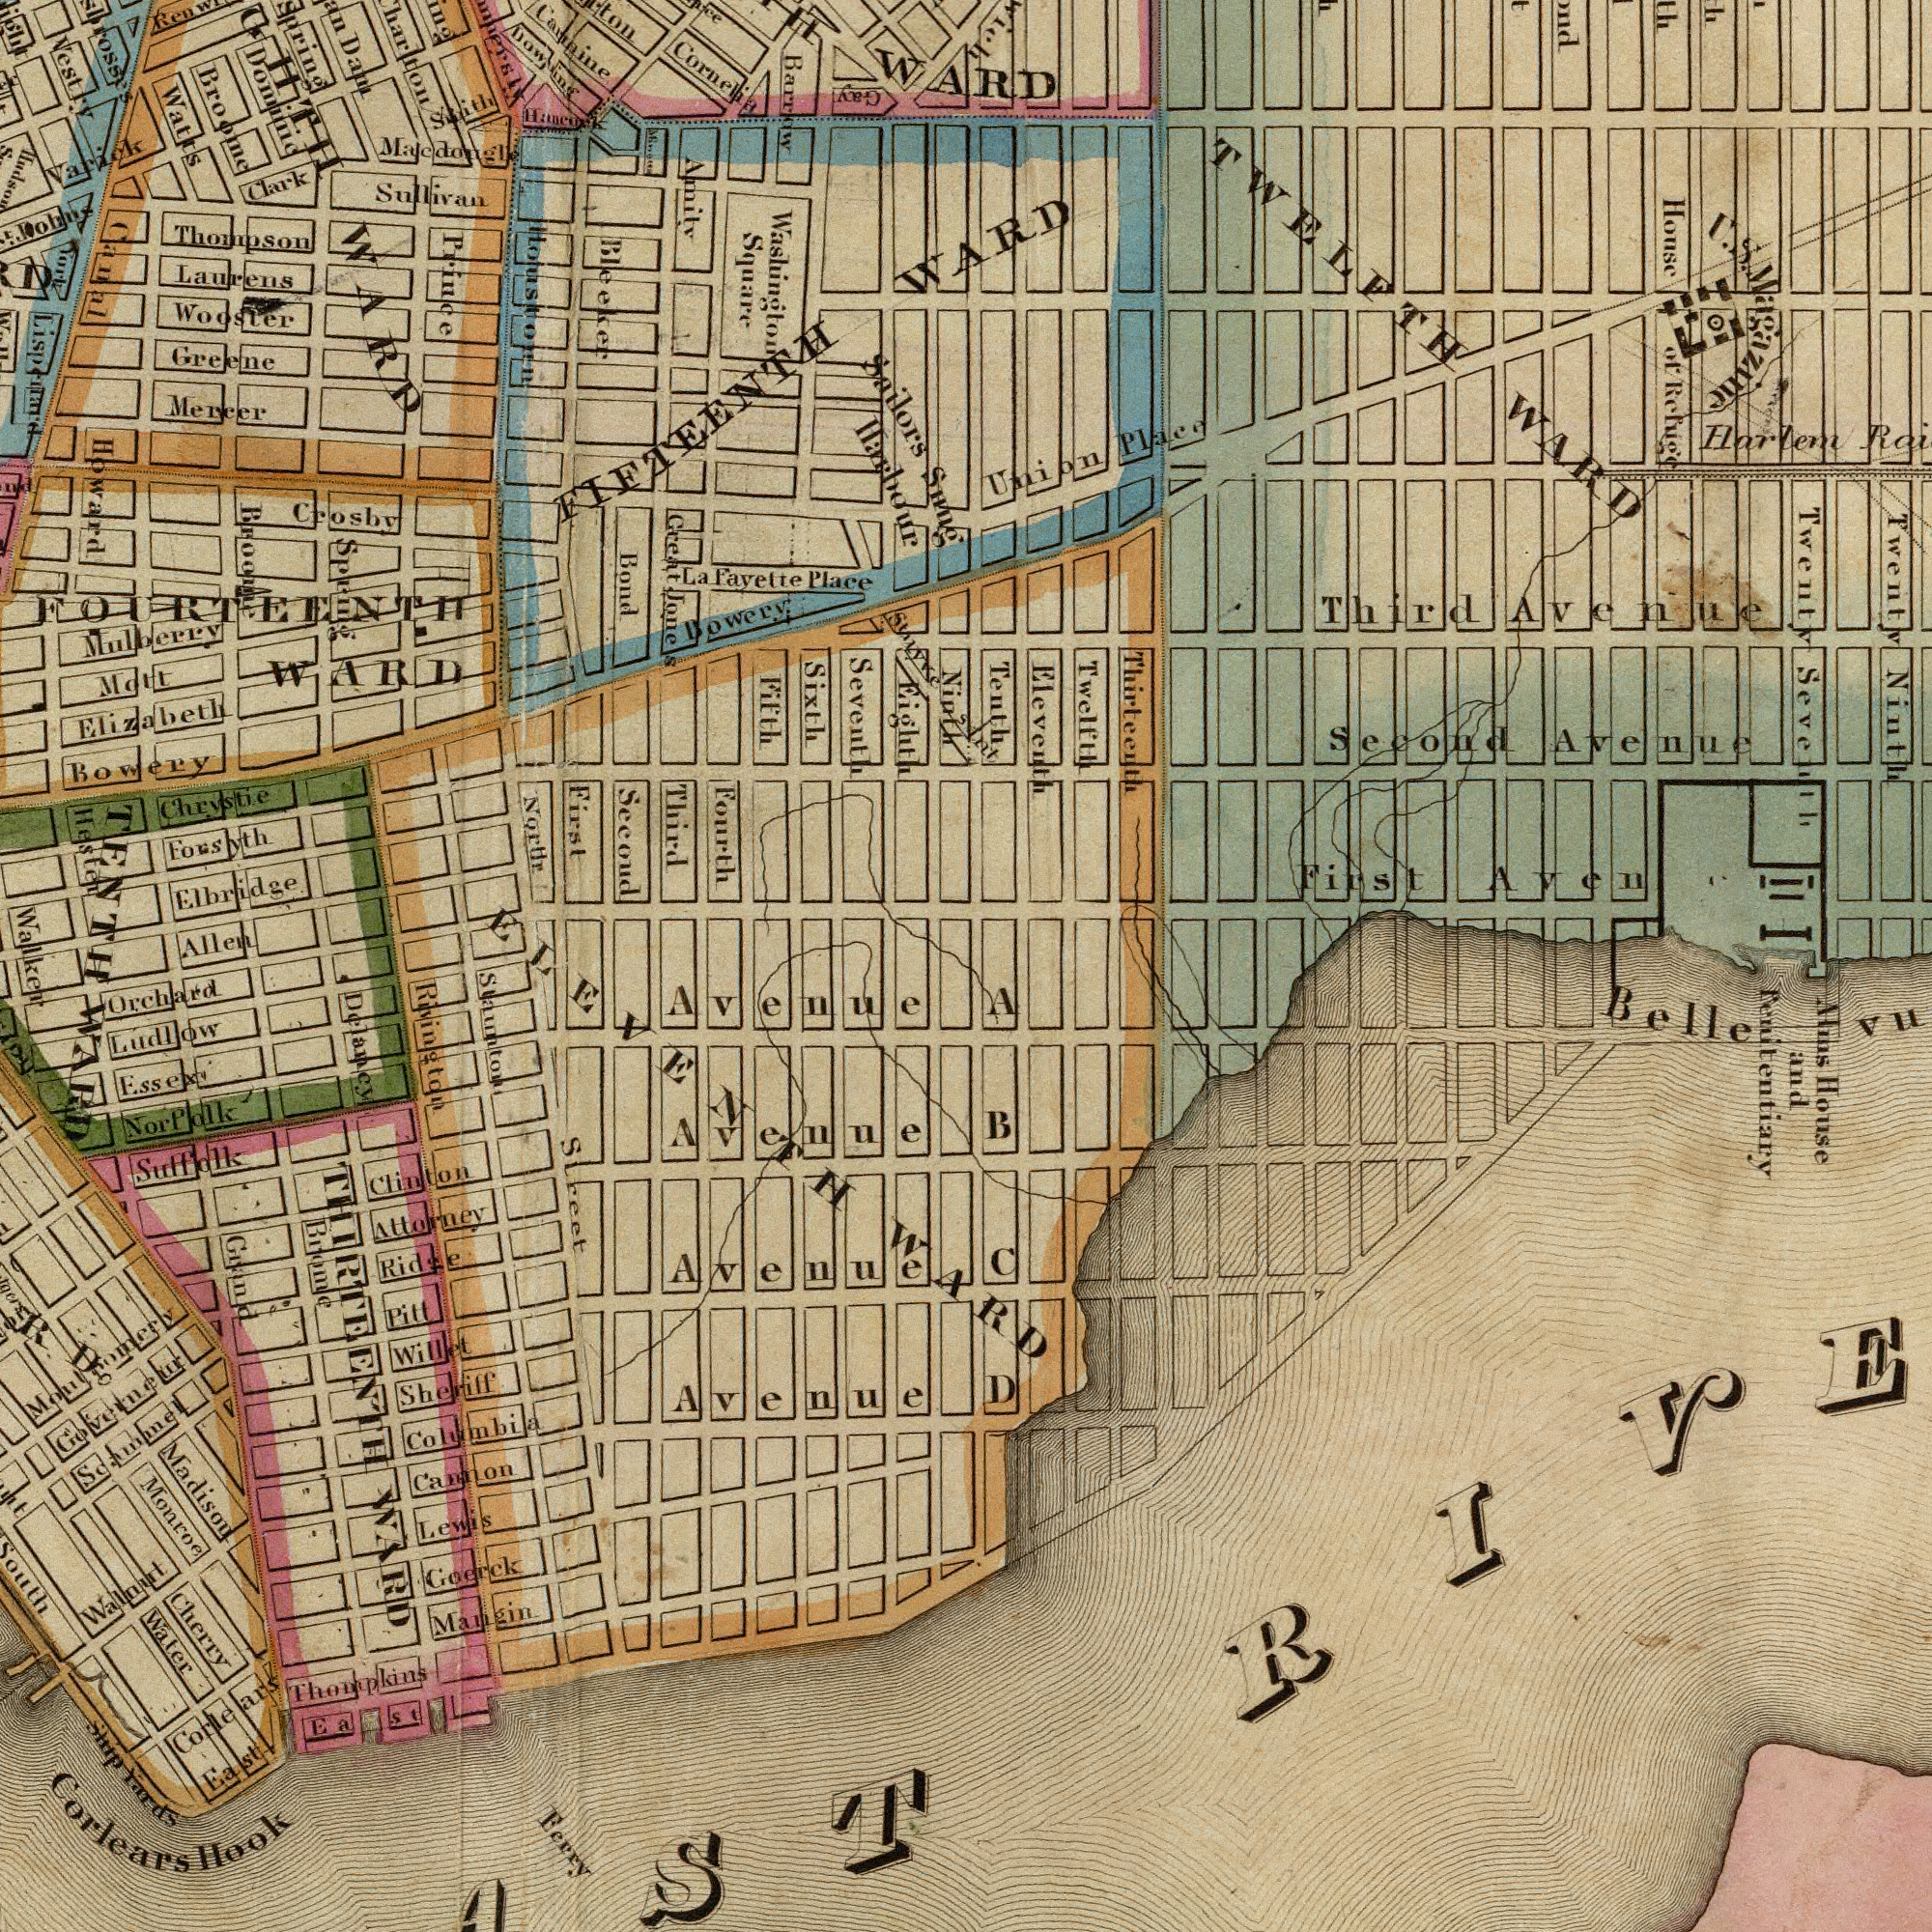What text can you see in the bottom-right section? D C A B Atns House and Penitentiary Bellevu What text appears in the top-right area of the image? WARD Twenty Ninth Second Avenue House of Refuge Twelfth Eleveith Thirteenth Union Place TWELFTH WARD First Aven Teuth Harlem Twenty Seventh II sant Third Avenue U. S. Magazine What text appears in the bottom-left area of the image? Street Walker Corlears Hook Ferry Cannon Avenue Goerck Madison Staunton Mangin Orchard Sheriff Sutfolk Lewis Water Willet Ludlow Columbia Walnurt Ridge Attorney Monroe Corlears Ship Yards Avenue Montgomery Brome Avenue East Cherry Thompkins Soammel Grand Rivington Avenue Essexi Governeur R. D. Ea St. Pill Clinton Delancy THIRTEENTH WARD Nor Polk WARD ELEVENTH WARD What text is shown in the top-left quadrant? Broome Comnine Laurens Thompson Greene Elbridge North Prince Watts Sullivan Fayette Place La Wooster Mulherry Third Fifth Sailors Snug Allen Sixth Crosby Seventh Washington Square Fourth Mott Mercer Cornelia Clark Bowery First Spring Varick Dam Chrystie Forsyth FOURTEENTH WARD Vestry WARD Bleeker Smith Hester Scound Amilv Bowery Ninth Bond Macdongle Creat Jones Elizabeth Barrow Harbour Johns Domine Stayve FIFTEENTH Broome Fork Spring Eighun Canal WARD Howard TENTH Gay Houstoon Hancock 